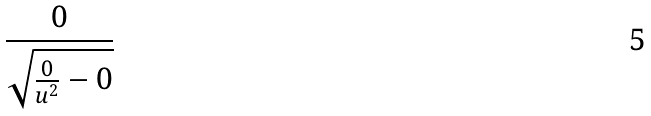<formula> <loc_0><loc_0><loc_500><loc_500>\frac { 0 } { \sqrt { \frac { 0 } { u ^ { 2 } } - 0 } }</formula> 